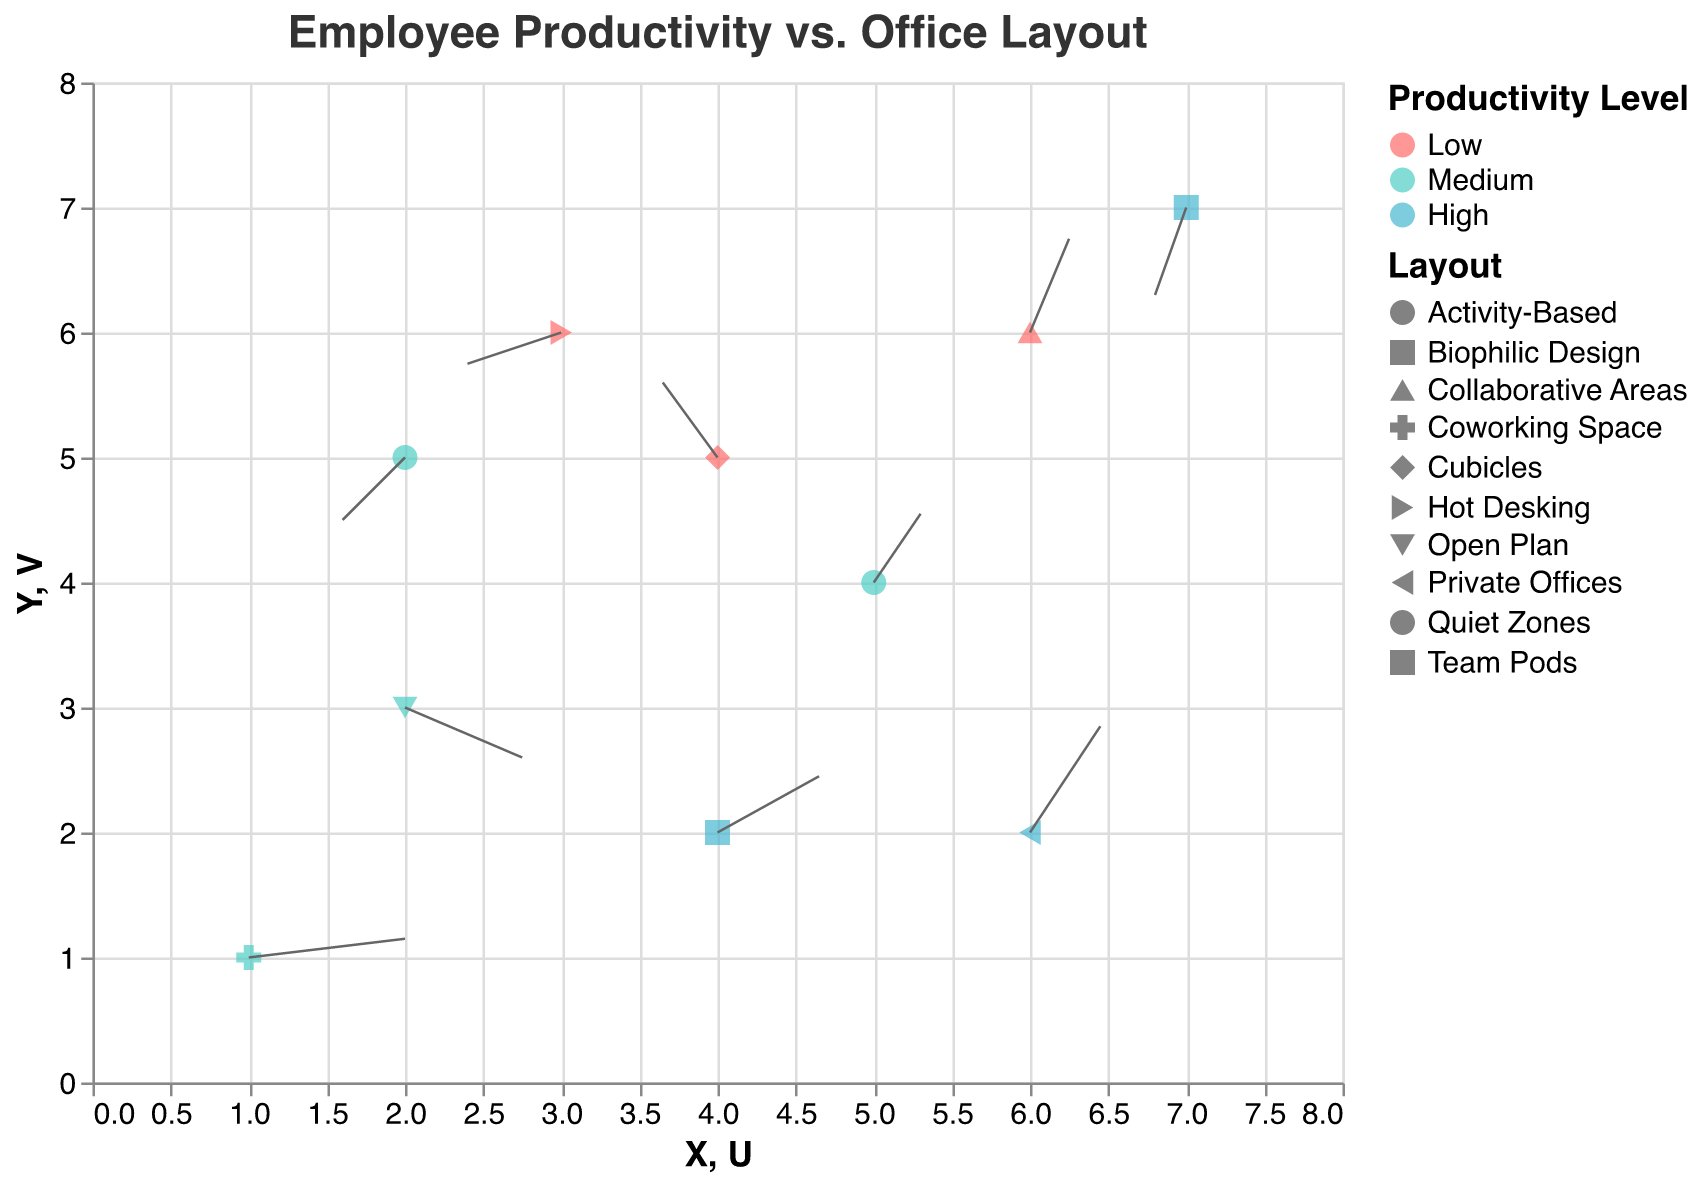What's the title of the plot? The title is displayed at the top of the plot and provides context about what the figure represents.
Answer: Employee Productivity vs. Office Layout How many different office layouts are represented in the plot? Each unique shape represents a different office layout, and there are seven different shapes visible in the figure.
Answer: 7 Which office layout has the highest productivity? Check the points colored in blue, which represents high productivity, and look for their associated office layout in the tooltip.
Answer: Private Offices, Team Pods, Biophilic Design What is the X and Y position of the point representing Hot Desking? Locate the point with the Hot Desking label and read off its X and Y coordinates.
Answer: X=3, Y=6 Which layout shows a positive change in the X direction and negative change in the Y direction? Look at the arrows starting from each layout's point; find the arrow pointing right (positive X) and down (negative Y).
Answer: Open Plan Which productivity level is most common in Activity-Based layouts? Locate the point representing Activity-Based, and check its color to determine the productivity level.
Answer: Medium Compare the arrows for Private Offices and Collaborative Areas. Which one shows a greater overall change in workspace design? Calculate the magnitude of the vectors for Private Offices (√(0.9² + 1.7²)) and Collaborative Areas (√(0.5² + 1.5²)), then compare.
Answer: Private Offices What's the direction of the arrow for the layout with the lowest starting X value? Find the arrow starting from the lowest X value (1,1 for Coworking Space) and observe its direction.
Answer: Positive X, Positive Y Which layout has the largest negative Y component in its vector? Identify the arrow pointing furthest downward by checking the V components and finding the most negative value.
Answer: Team Pods For the Cubicles layout, if you walk from the start of the arrow to the end, would you end up in a higher or lower Y coordinate? Observe the direction of the arrow for Cubicles; if the arrow points upward, the Y coordinate increases; if downward, it decreases.
Answer: Higher 